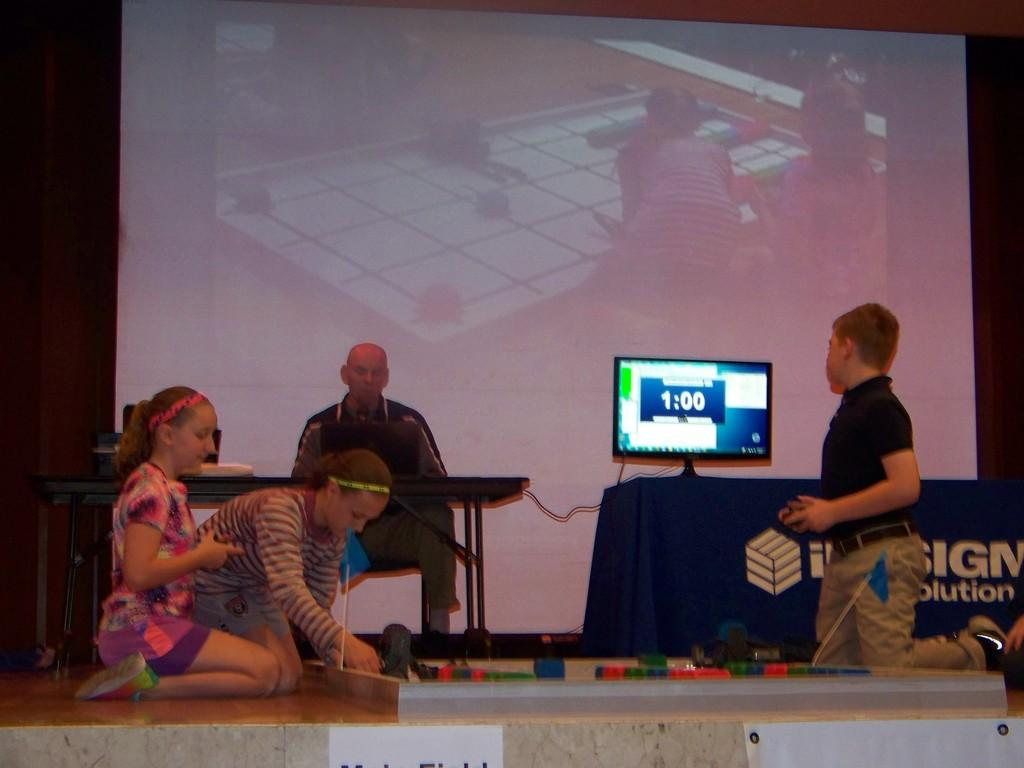<image>
Relay a brief, clear account of the picture shown. Students playing a game on stage with a timer for a Solutions company. 